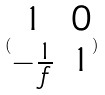Convert formula to latex. <formula><loc_0><loc_0><loc_500><loc_500>( \begin{matrix} 1 & 0 \\ - \frac { 1 } { f } & 1 \end{matrix} )</formula> 